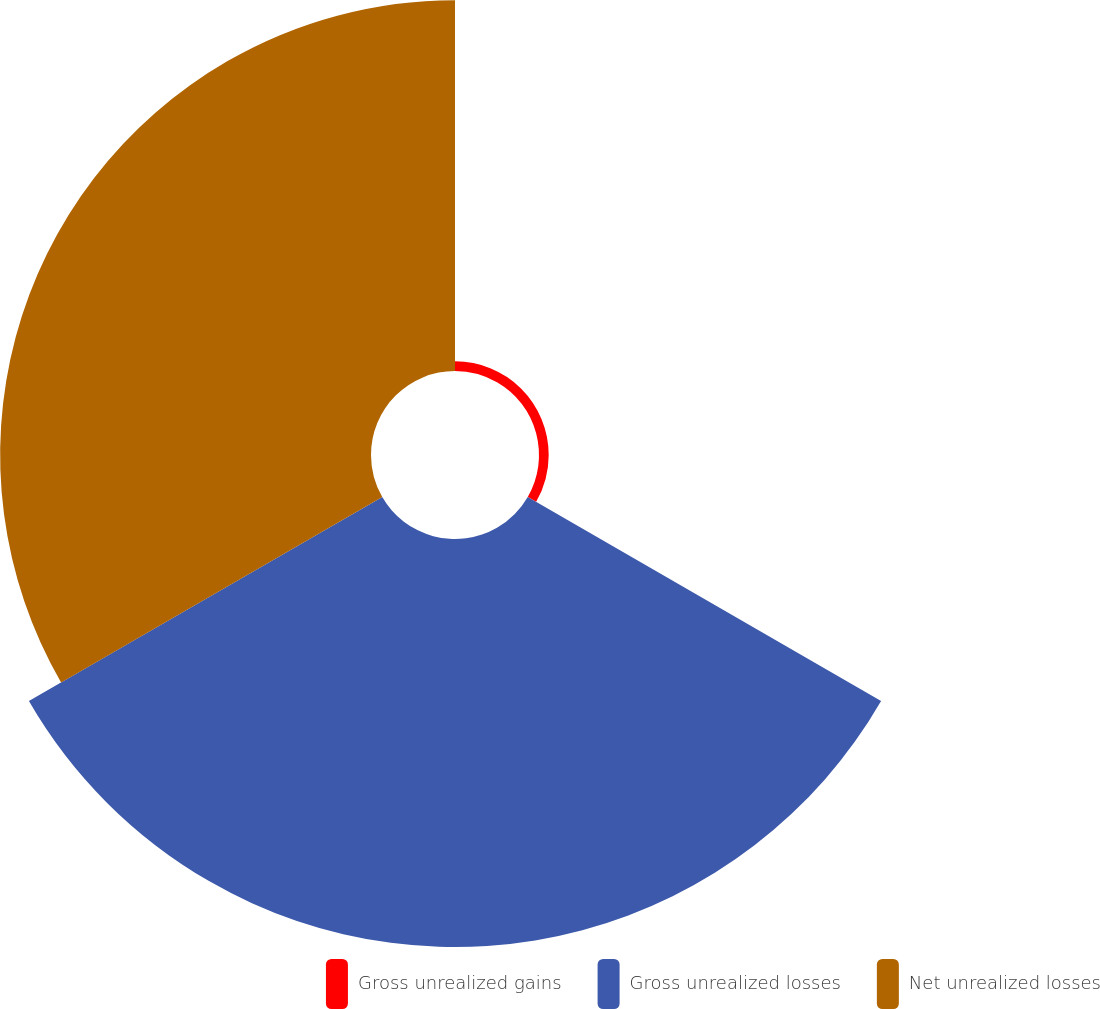<chart> <loc_0><loc_0><loc_500><loc_500><pie_chart><fcel>Gross unrealized gains<fcel>Gross unrealized losses<fcel>Net unrealized losses<nl><fcel>1.23%<fcel>51.74%<fcel>47.03%<nl></chart> 